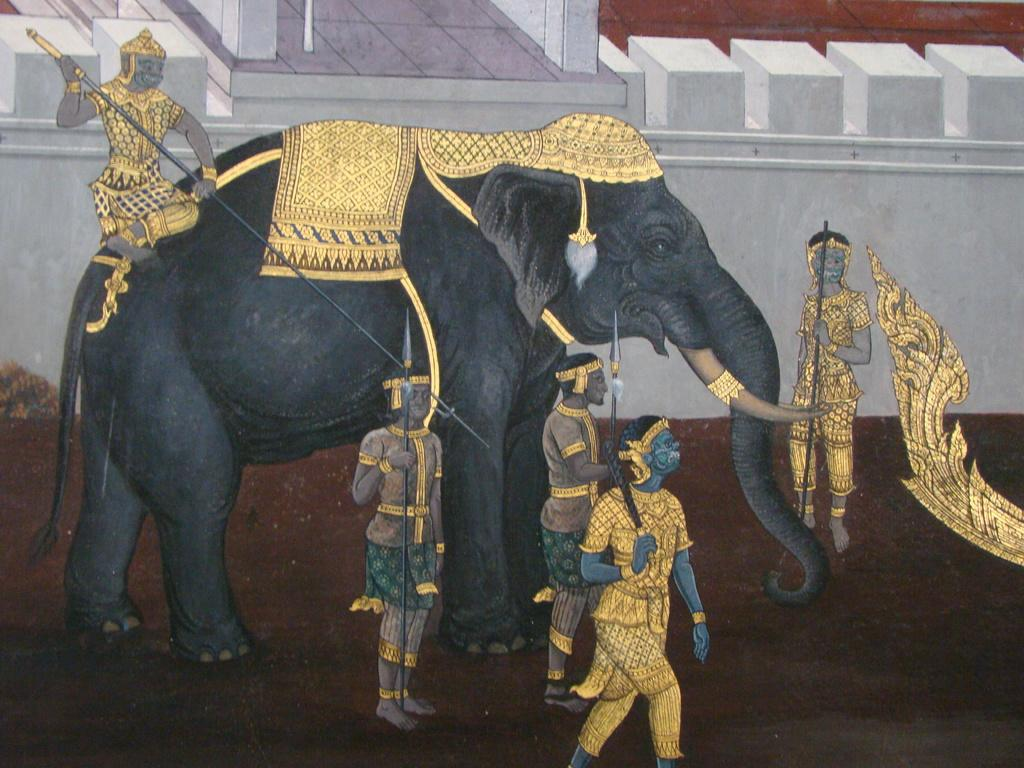What is the main subject of the image? The main subject of the image is a painting. What can be seen in the painting? The painting contains a few people holding objects, a person sitting on an elephant, and a house. What type of hair can be seen on the fifth person in the painting? There is no fifth person in the painting, and therefore no hair can be observed on them. 